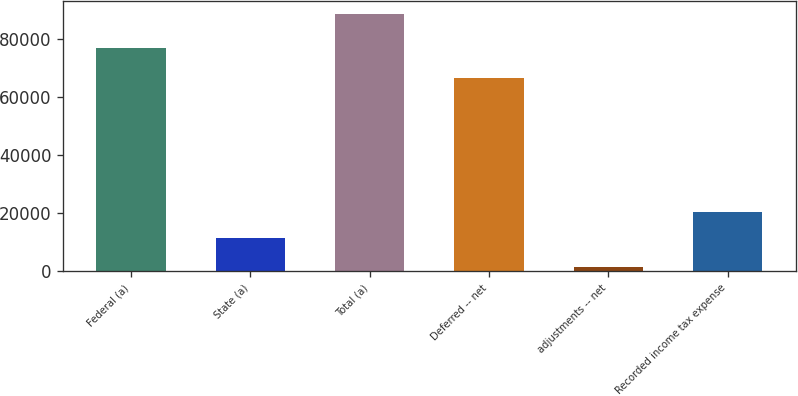<chart> <loc_0><loc_0><loc_500><loc_500><bar_chart><fcel>Federal (a)<fcel>State (a)<fcel>Total (a)<fcel>Deferred -- net<fcel>adjustments -- net<fcel>Recorded income tax expense<nl><fcel>77074<fcel>11523<fcel>88597<fcel>66633<fcel>1500<fcel>20464<nl></chart> 